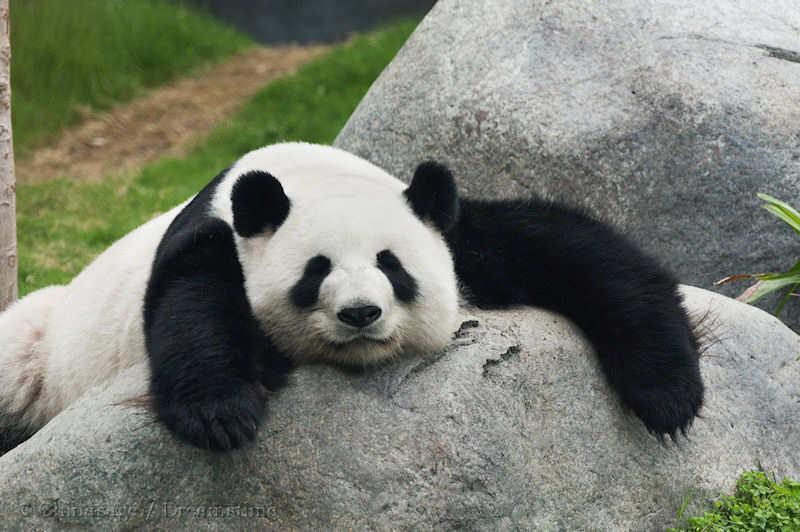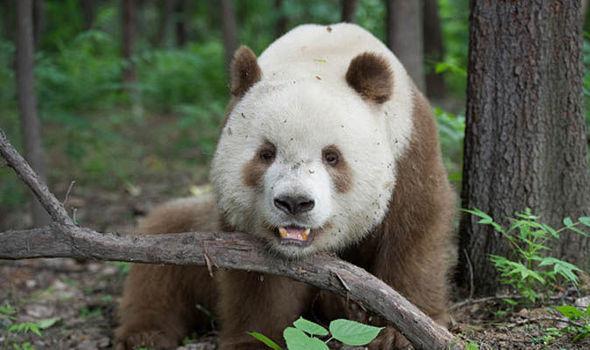The first image is the image on the left, the second image is the image on the right. Considering the images on both sides, is "There are at least two pandas in one of the images." valid? Answer yes or no. No. 